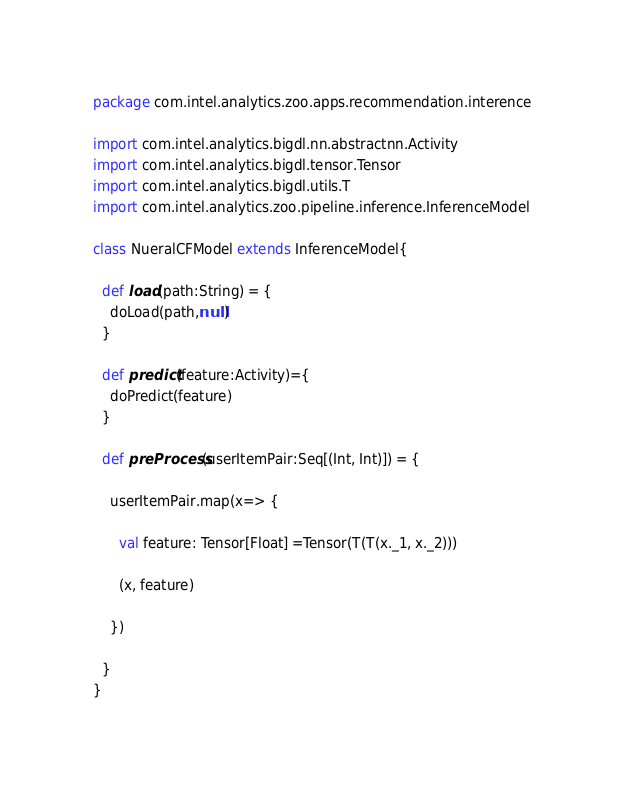<code> <loc_0><loc_0><loc_500><loc_500><_Scala_>package com.intel.analytics.zoo.apps.recommendation.interence

import com.intel.analytics.bigdl.nn.abstractnn.Activity
import com.intel.analytics.bigdl.tensor.Tensor
import com.intel.analytics.bigdl.utils.T
import com.intel.analytics.zoo.pipeline.inference.InferenceModel

class NueralCFModel extends InferenceModel{

  def load(path:String) = {
    doLoad(path,null)
  }

  def predict(feature:Activity)={
    doPredict(feature)
  }

  def preProcess(userItemPair:Seq[(Int, Int)]) = {

    userItemPair.map(x=> {

      val feature: Tensor[Float] =Tensor(T(T(x._1, x._2)))

      (x, feature)

    })

  }
}
</code> 